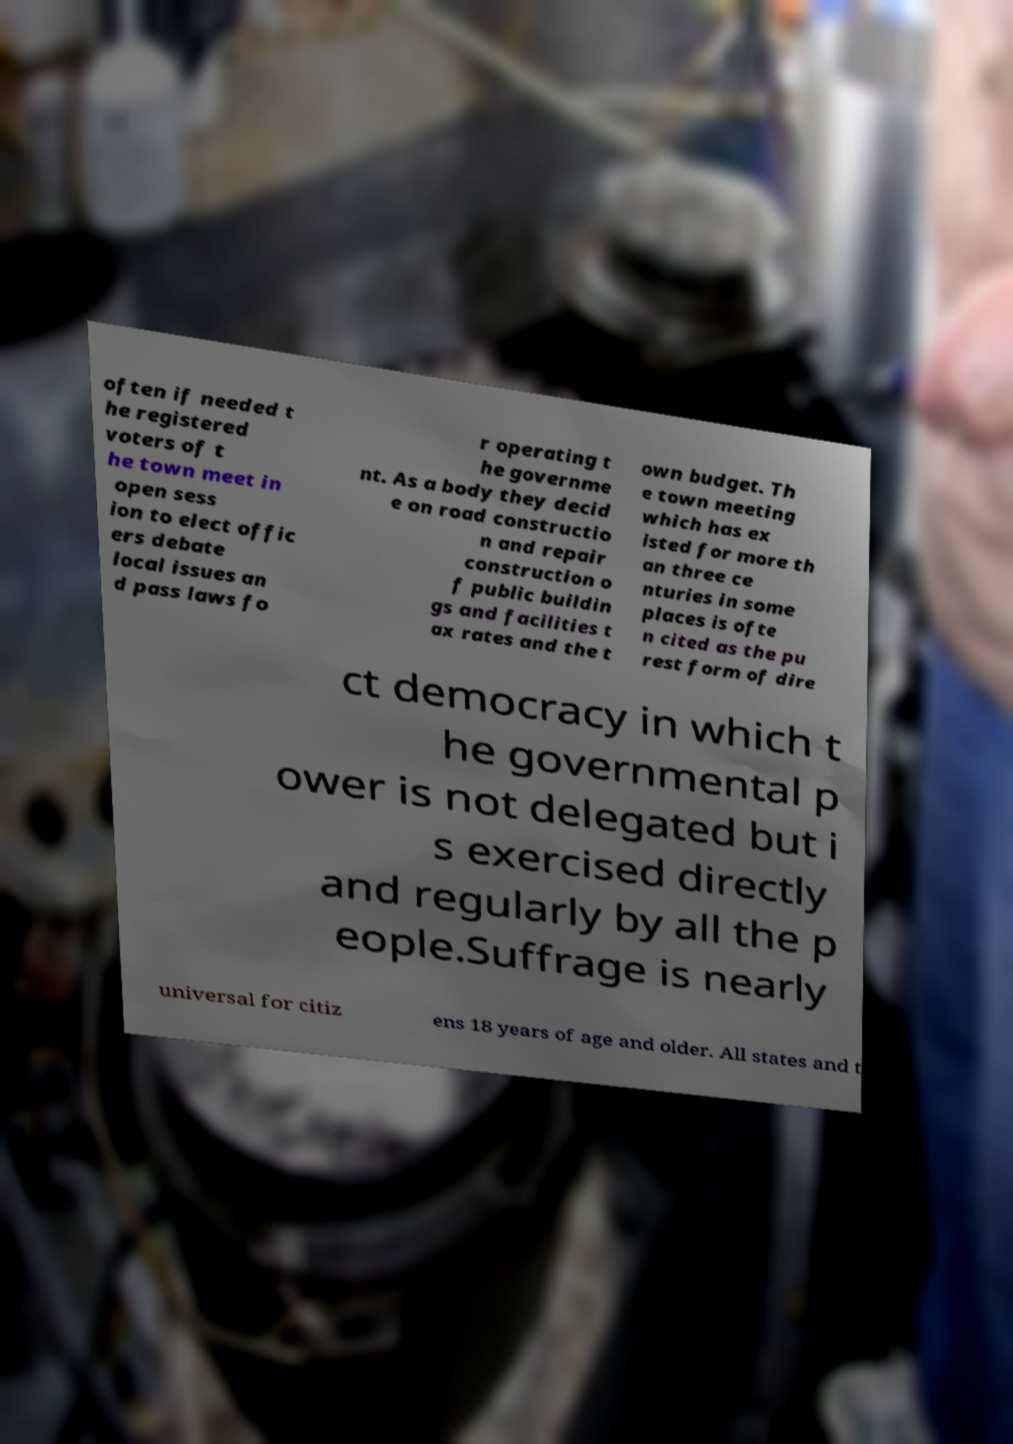Can you read and provide the text displayed in the image?This photo seems to have some interesting text. Can you extract and type it out for me? often if needed t he registered voters of t he town meet in open sess ion to elect offic ers debate local issues an d pass laws fo r operating t he governme nt. As a body they decid e on road constructio n and repair construction o f public buildin gs and facilities t ax rates and the t own budget. Th e town meeting which has ex isted for more th an three ce nturies in some places is ofte n cited as the pu rest form of dire ct democracy in which t he governmental p ower is not delegated but i s exercised directly and regularly by all the p eople.Suffrage is nearly universal for citiz ens 18 years of age and older. All states and t 